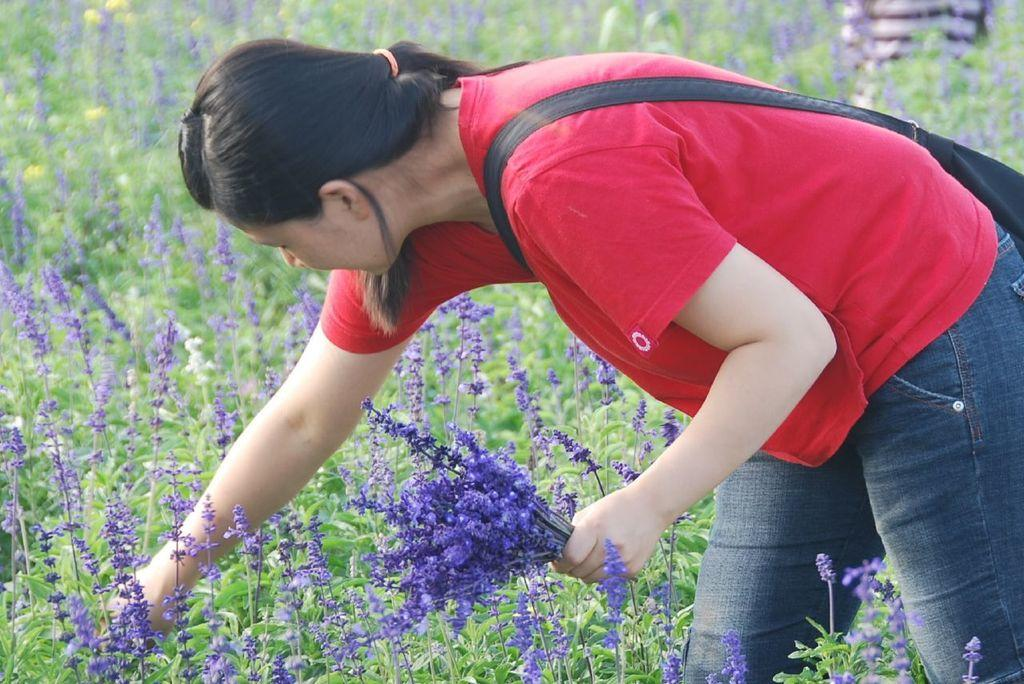Who is present in the image? There is a person in the image. What is the person doing in the image? The person is plucking flowers. What type of plants can be seen in the image? There are plants with flowers in the image. What type of plastic material can be seen in the image? There is no plastic material present in the image. How does the person laugh while plucking flowers in the image? The person is not laughing in the image; they are focused on plucking flowers. 